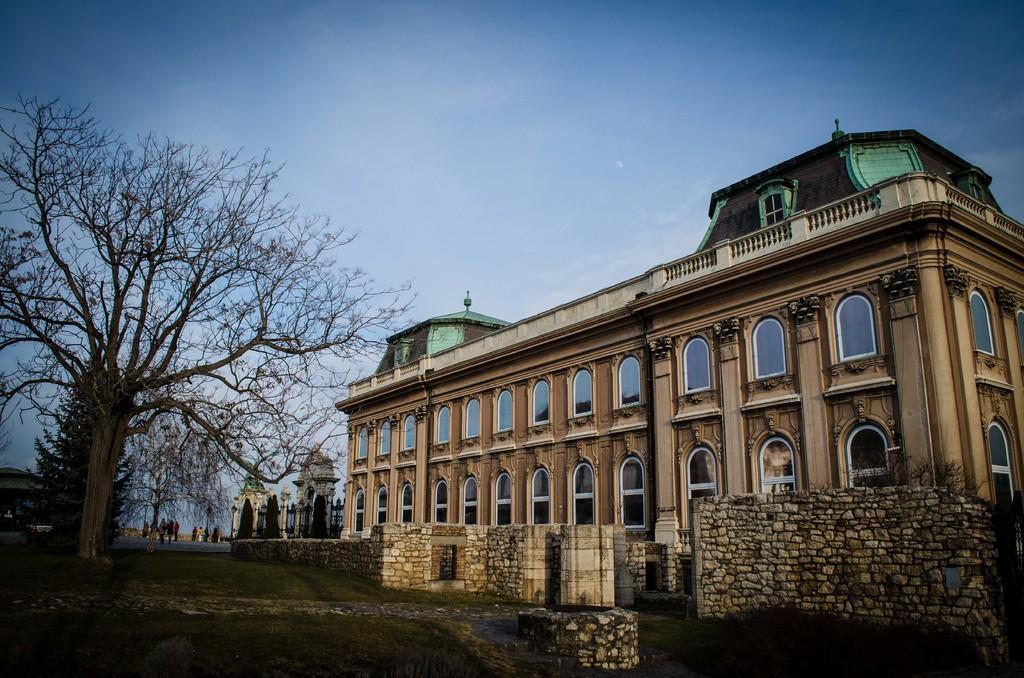Please provide a concise description of this image. In this image I can see a building, glass windows, trees, stone walls and few people. The sky is in blue color. 